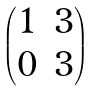<formula> <loc_0><loc_0><loc_500><loc_500>\begin{pmatrix} 1 & 3 \\ 0 & 3 \end{pmatrix}</formula> 